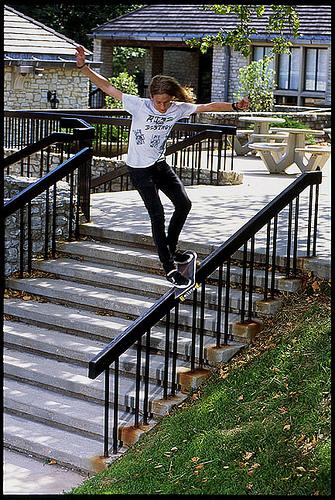Is the skateboarder going up?
Quick response, please. No. How many steps are there?
Give a very brief answer. 9. What is the skateboard on?
Give a very brief answer. Railing. 